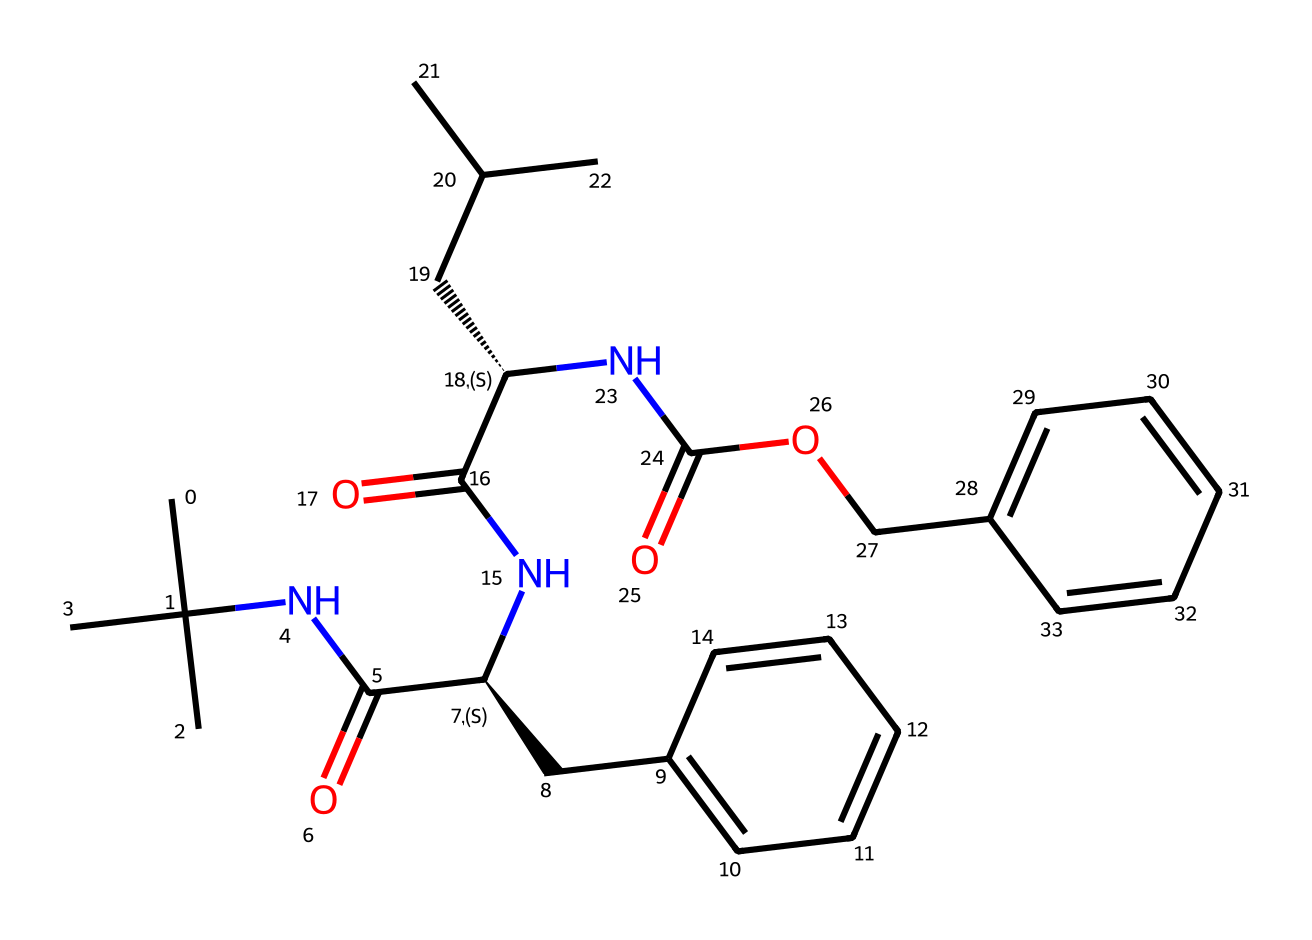What is the molecular formula of this compound? To find the molecular formula, we need to count the number of each type of atom present in the chemical structure based on the SMILES representation. By analyzing it, we identify 21 carbon (C) atoms, 31 hydrogen (H) atoms, 4 nitrogen (N) atoms, and 5 oxygen (O) atoms. This gives the overall molecular formula as C21H31N4O5.
Answer: C21H31N4O5 How many chiral centers are present in this compound? The chiral centers in a compound are typically indicated by the "@" symbol in the SMILES string. In this case, there are two "@H" indicators, which denote two chiral centers in the structure.
Answer: 2 What type of amide is present in this compound? Amides have a carbonyl (C=O) group attached to a nitrogen atom (N). Examining the structure reveals that the carbonyl groups are indeed attached to nitrogen atoms, confirming that this compound contains amides. Considering the structure, these are secondary amides due to the presence of alkyl groups attached to the nitrogen atom.
Answer: secondary amide What is the primary functional group in this compound? The primary functional groups identified in the chemical structure include amide and ester groups. The presence of the carbonyl (C=O) linked to nitrogen (N) signifies amide, and the carbonyl and oxygen linking an alkyl group points to the ester. The primary functional group considering most of the structure is amide due to the common presence of these groups.
Answer: amide Is this compound likely to have a sweet or bitter taste? Compounds with amide functional groups can exhibit a variety of tastes, but amides are often neutral to slightly bitter in flavor. The structure suggests an influence from aromatic components that might also contribute to a more complex taste profile, but in general, the presence of nitrogen atoms and the structural composition leans towards a bitter profile.
Answer: bitter 